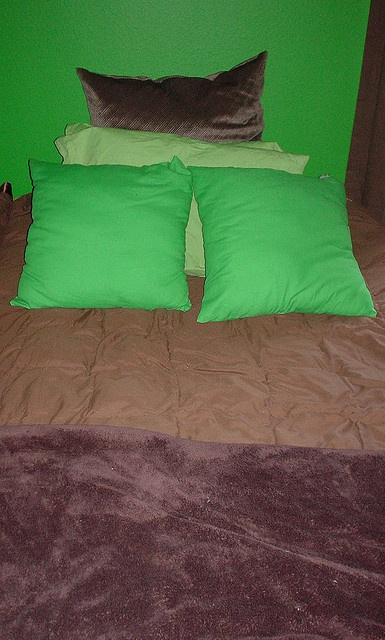Describe the objects in this image and their specific colors. I can see a bed in darkgreen, maroon, brown, gray, and green tones in this image. 